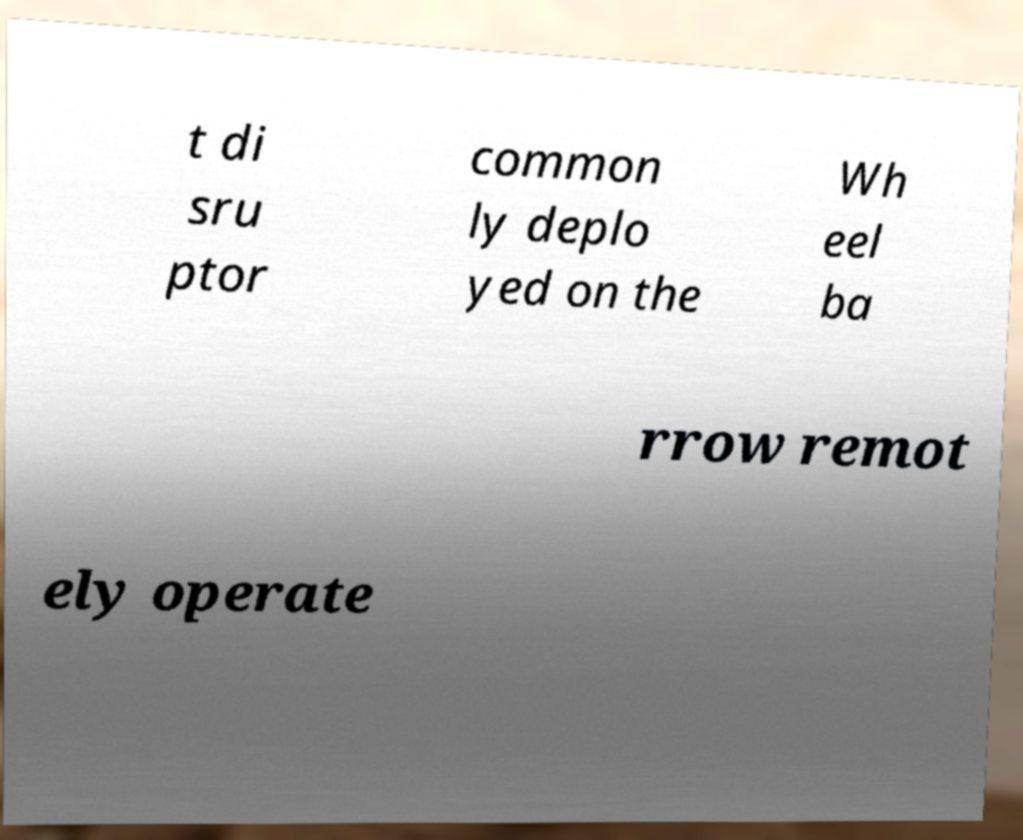What messages or text are displayed in this image? I need them in a readable, typed format. t di sru ptor common ly deplo yed on the Wh eel ba rrow remot ely operate 